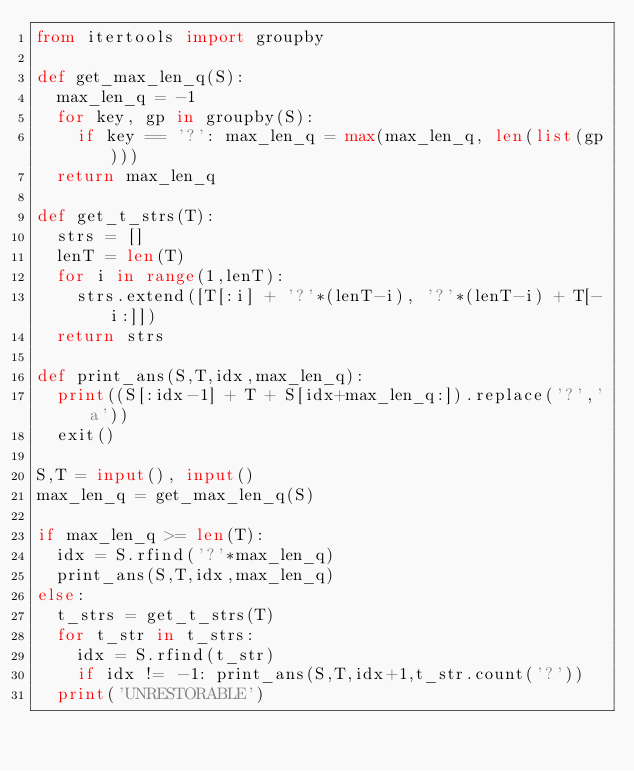<code> <loc_0><loc_0><loc_500><loc_500><_Python_>from itertools import groupby

def get_max_len_q(S):
  max_len_q = -1
  for key, gp in groupby(S):
    if key == '?': max_len_q = max(max_len_q, len(list(gp)))
  return max_len_q

def get_t_strs(T):
  strs = []
  lenT = len(T)
  for i in range(1,lenT):
    strs.extend([T[:i] + '?'*(lenT-i), '?'*(lenT-i) + T[-i:]])
  return strs

def print_ans(S,T,idx,max_len_q):
  print((S[:idx-1] + T + S[idx+max_len_q:]).replace('?','a'))
  exit()

S,T = input(), input()
max_len_q = get_max_len_q(S)

if max_len_q >= len(T):
  idx = S.rfind('?'*max_len_q)
  print_ans(S,T,idx,max_len_q)
else:
  t_strs = get_t_strs(T)
  for t_str in t_strs:
    idx = S.rfind(t_str)
    if idx != -1: print_ans(S,T,idx+1,t_str.count('?'))
  print('UNRESTORABLE')     </code> 